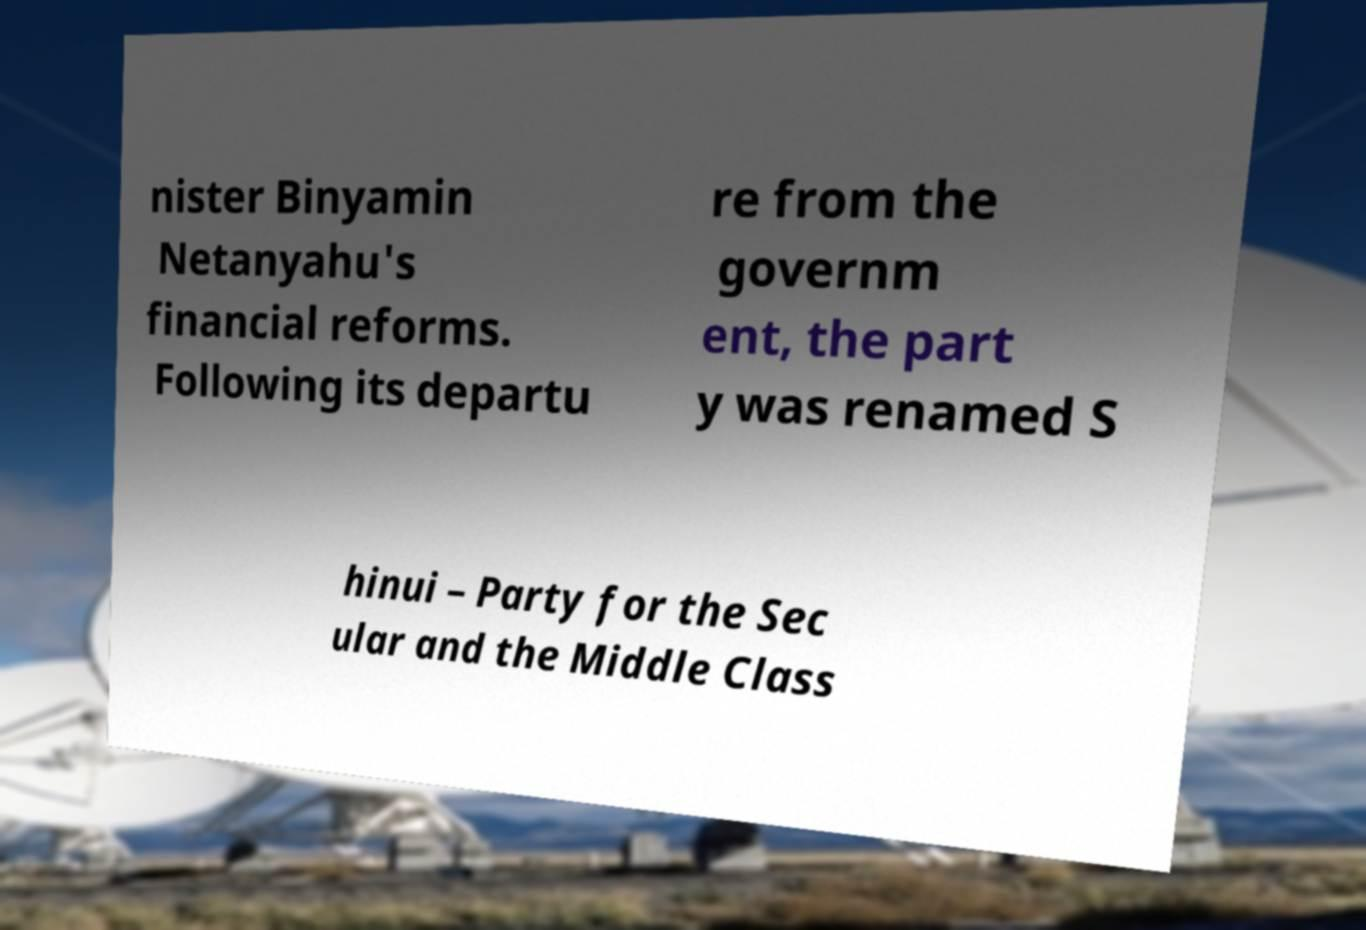There's text embedded in this image that I need extracted. Can you transcribe it verbatim? nister Binyamin Netanyahu's financial reforms. Following its departu re from the governm ent, the part y was renamed S hinui – Party for the Sec ular and the Middle Class 